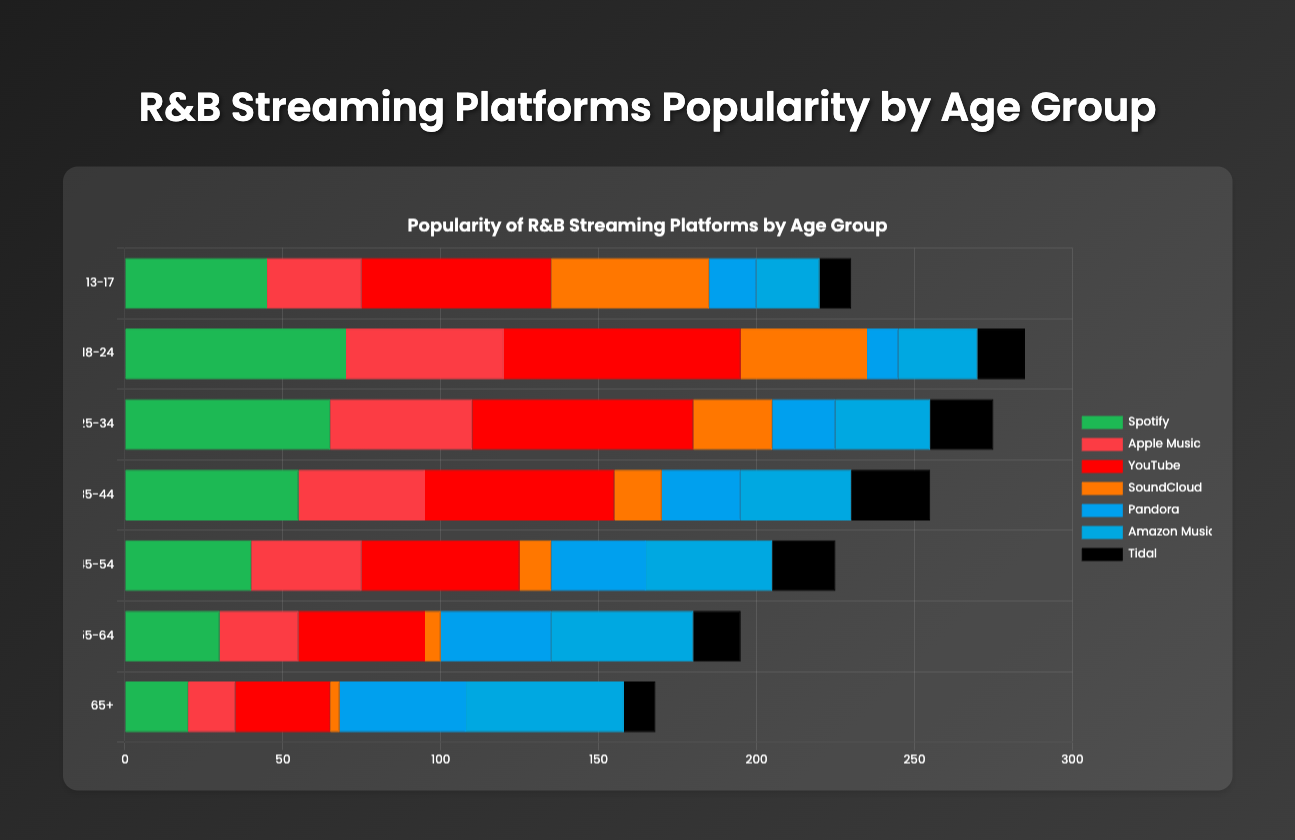Which age group has the highest percentage of Spotify users? By looking at the horizontal bars for Spotify across all age groups, the 18-24 age group has the tallest bar, indicating the highest percentage for Spotify usage.
Answer: 18-24 Which platform is most popular among the 13-17 age group? By observing the tallest bar in the 13-17 age group's section, the YouTube bar is the longest, indicating it is the most popular platform among this age group.
Answer: YouTube What is the difference in Amazon Music popularity between the 25-34 and 65+ age groups? The bar for Amazon Music in the 25-34 group reaches the 30 mark, while in the 65+ group it reaches the 50 mark. The difference is calculated as 50 - 30 = 20.
Answer: 20 Which platform sees the largest decrease in popularity from the 13-17 to the 25-34 age group? By comparing the lengths of bars for each platform between the 13-17 and 25-34 age ranges, SoundCloud shows the largest decrease, dropping from 50 to 25, resulting in a decrease of 25.
Answer: SoundCloud What is the average popularity of YouTube across all age groups? Add the percentages of YouTube for all age groups and divide by the number of groups: (60 + 75 + 70 + 60 + 50 + 40 + 30) / 7 = 385 / 7 ≈ 55.
Answer: 55 What's the total popularity percentage for the Tidal platform across all age groups? Sum the percentages of Tidal usage in each age group: 10 + 15 + 20 + 25 + 20 + 15 + 10 = 115.
Answer: 115 Is Pandora more popular than SoundCloud among the 35-44 age group? The bar for Pandora reaches 25, while the bar for SoundCloud reaches 15 for the 35-44 age group. Therefore, Pandora is more popular.
Answer: Yes Which platform has a consistent increase in popularity as age increases from 13-17 to 65+? Observing each platform's bars across age groups shows that Amazon Music consistently increases in popularity from one age group to the next: 20, 25, 30, 35, 40, 45, 50.
Answer: Amazon Music 